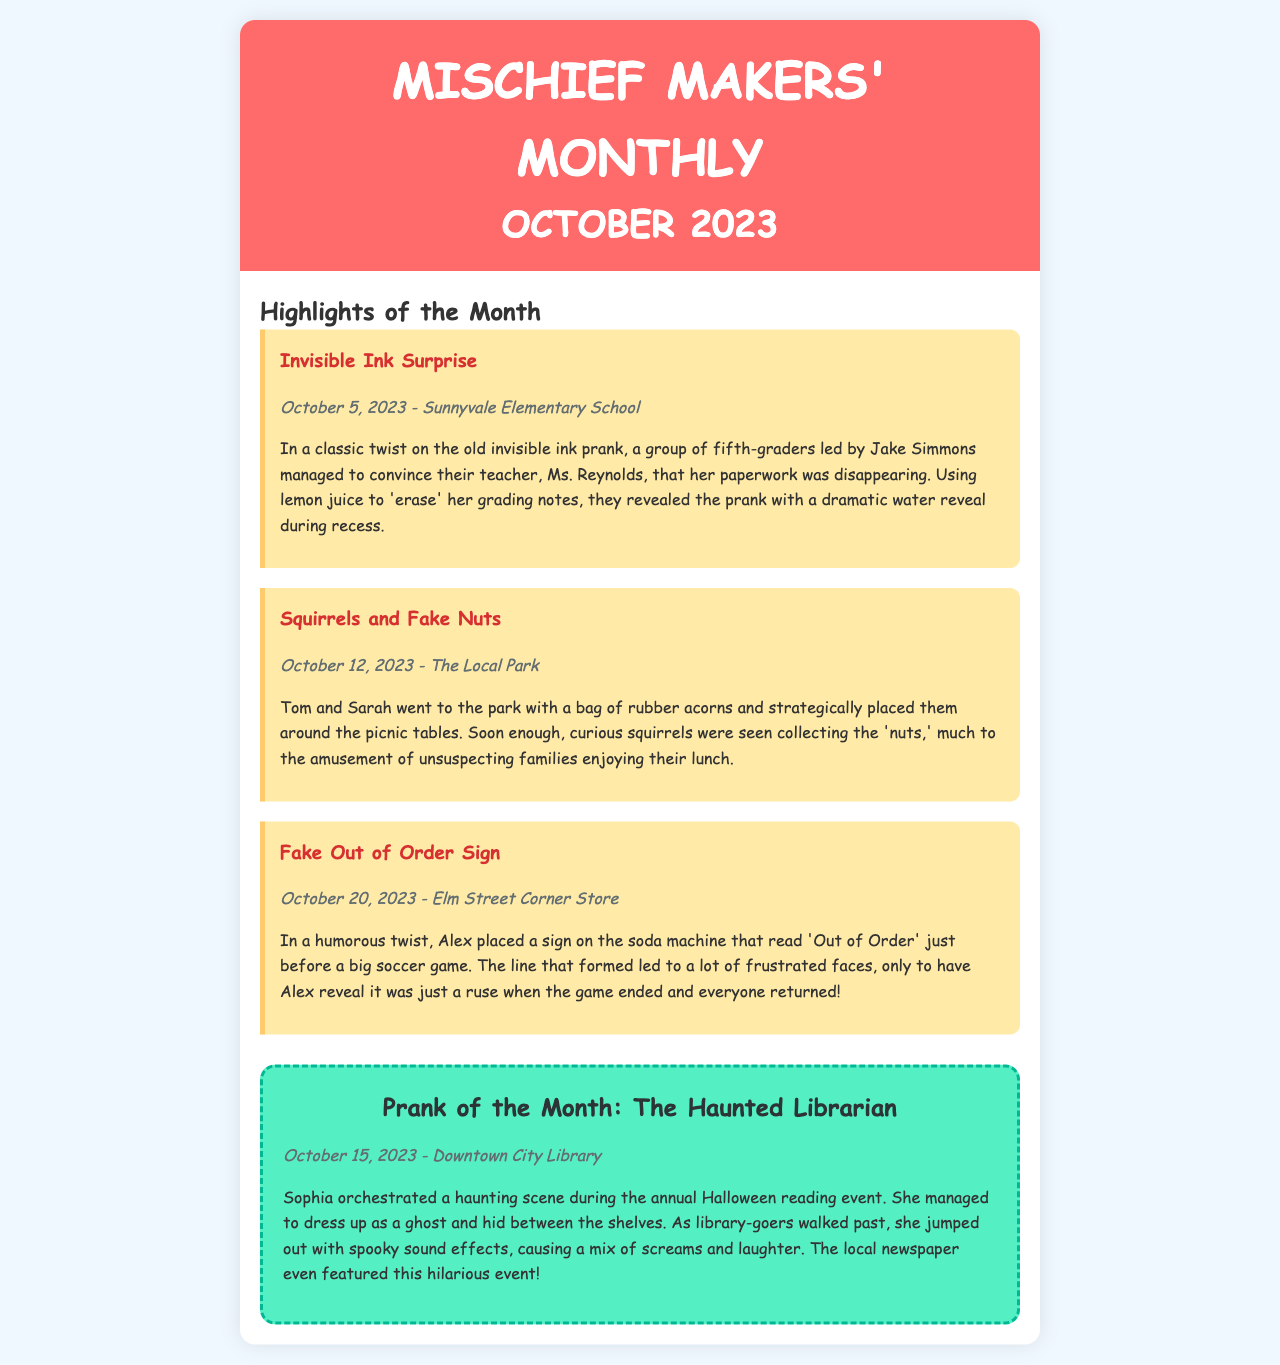What was the main prank on October 15, 2023? The main prank was orchestrated by Sophia, who dressed up as a ghost during a Halloween reading event.
Answer: The Haunted Librarian Who led the prank involving invisible ink? Jake Simmons led the prank involving invisible ink at Sunnyvale Elementary School.
Answer: Jake Simmons How many highlights of the month are listed in the newsletter? There are three highlights of the month listed in the newsletter.
Answer: Three What was used to create the 'nuts' in the prank at the park? Tom and Sarah used rubber acorns to create the 'nuts' prank.
Answer: Rubber acorns Which location featured in the prank of the month? The prank of the month took place at the Downtown City Library.
Answer: Downtown City Library When did the prank involving a fake out-of-order sign occur? The prank involving a fake out-of-order sign occurred on October 20, 2023.
Answer: October 20, 2023 What was the reaction of the library-goers when Sophia jumped out? The library-goers reacted with a mix of screams and laughter.
Answer: Screams and laughter What is the newsletter titled? The newsletter is titled Mischief Makers' Monthly.
Answer: Mischief Makers' Monthly 